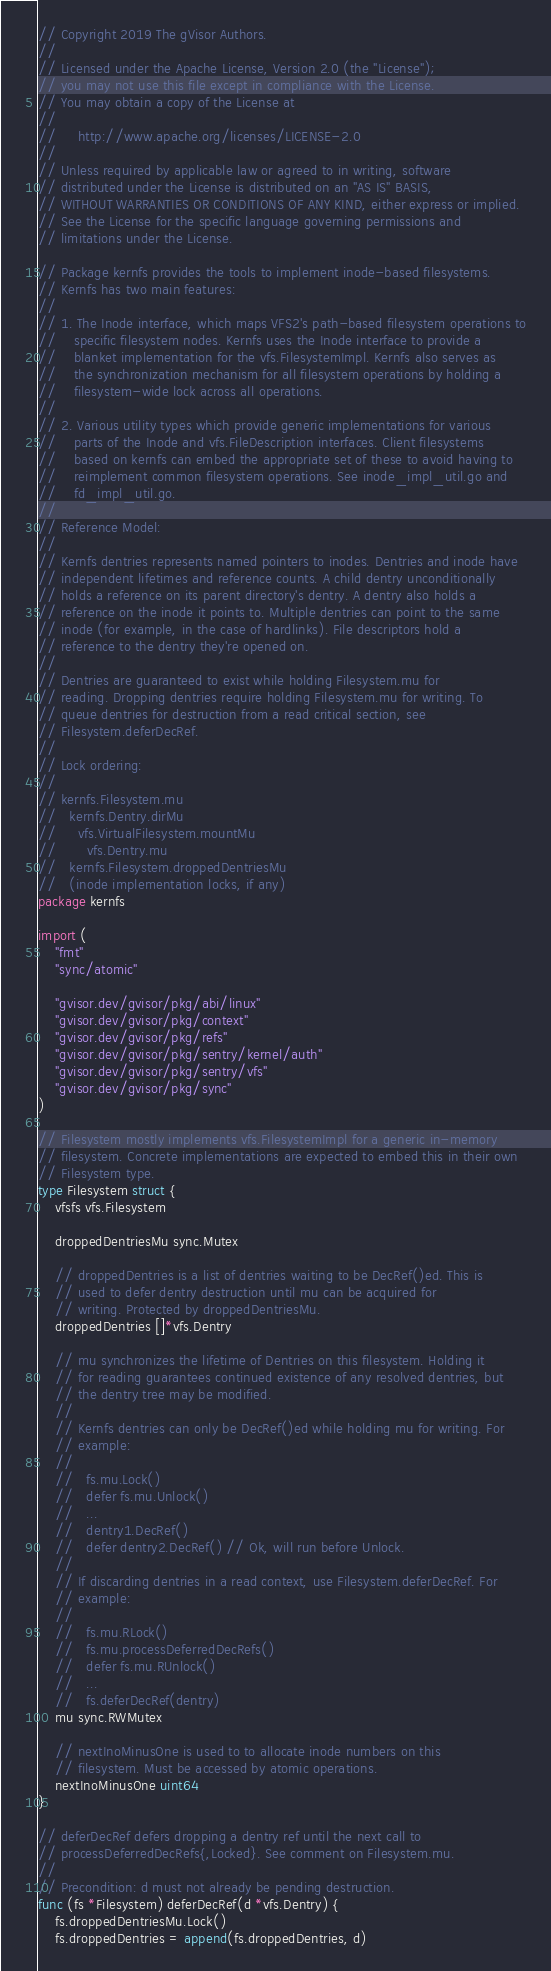<code> <loc_0><loc_0><loc_500><loc_500><_Go_>// Copyright 2019 The gVisor Authors.
//
// Licensed under the Apache License, Version 2.0 (the "License");
// you may not use this file except in compliance with the License.
// You may obtain a copy of the License at
//
//     http://www.apache.org/licenses/LICENSE-2.0
//
// Unless required by applicable law or agreed to in writing, software
// distributed under the License is distributed on an "AS IS" BASIS,
// WITHOUT WARRANTIES OR CONDITIONS OF ANY KIND, either express or implied.
// See the License for the specific language governing permissions and
// limitations under the License.

// Package kernfs provides the tools to implement inode-based filesystems.
// Kernfs has two main features:
//
// 1. The Inode interface, which maps VFS2's path-based filesystem operations to
//    specific filesystem nodes. Kernfs uses the Inode interface to provide a
//    blanket implementation for the vfs.FilesystemImpl. Kernfs also serves as
//    the synchronization mechanism for all filesystem operations by holding a
//    filesystem-wide lock across all operations.
//
// 2. Various utility types which provide generic implementations for various
//    parts of the Inode and vfs.FileDescription interfaces. Client filesystems
//    based on kernfs can embed the appropriate set of these to avoid having to
//    reimplement common filesystem operations. See inode_impl_util.go and
//    fd_impl_util.go.
//
// Reference Model:
//
// Kernfs dentries represents named pointers to inodes. Dentries and inode have
// independent lifetimes and reference counts. A child dentry unconditionally
// holds a reference on its parent directory's dentry. A dentry also holds a
// reference on the inode it points to. Multiple dentries can point to the same
// inode (for example, in the case of hardlinks). File descriptors hold a
// reference to the dentry they're opened on.
//
// Dentries are guaranteed to exist while holding Filesystem.mu for
// reading. Dropping dentries require holding Filesystem.mu for writing. To
// queue dentries for destruction from a read critical section, see
// Filesystem.deferDecRef.
//
// Lock ordering:
//
// kernfs.Filesystem.mu
//   kernfs.Dentry.dirMu
//     vfs.VirtualFilesystem.mountMu
//       vfs.Dentry.mu
//   kernfs.Filesystem.droppedDentriesMu
//   (inode implementation locks, if any)
package kernfs

import (
	"fmt"
	"sync/atomic"

	"gvisor.dev/gvisor/pkg/abi/linux"
	"gvisor.dev/gvisor/pkg/context"
	"gvisor.dev/gvisor/pkg/refs"
	"gvisor.dev/gvisor/pkg/sentry/kernel/auth"
	"gvisor.dev/gvisor/pkg/sentry/vfs"
	"gvisor.dev/gvisor/pkg/sync"
)

// Filesystem mostly implements vfs.FilesystemImpl for a generic in-memory
// filesystem. Concrete implementations are expected to embed this in their own
// Filesystem type.
type Filesystem struct {
	vfsfs vfs.Filesystem

	droppedDentriesMu sync.Mutex

	// droppedDentries is a list of dentries waiting to be DecRef()ed. This is
	// used to defer dentry destruction until mu can be acquired for
	// writing. Protected by droppedDentriesMu.
	droppedDentries []*vfs.Dentry

	// mu synchronizes the lifetime of Dentries on this filesystem. Holding it
	// for reading guarantees continued existence of any resolved dentries, but
	// the dentry tree may be modified.
	//
	// Kernfs dentries can only be DecRef()ed while holding mu for writing. For
	// example:
	//
	//   fs.mu.Lock()
	//   defer fs.mu.Unlock()
	//   ...
	//   dentry1.DecRef()
	//   defer dentry2.DecRef() // Ok, will run before Unlock.
	//
	// If discarding dentries in a read context, use Filesystem.deferDecRef. For
	// example:
	//
	//   fs.mu.RLock()
	//   fs.mu.processDeferredDecRefs()
	//   defer fs.mu.RUnlock()
	//   ...
	//   fs.deferDecRef(dentry)
	mu sync.RWMutex

	// nextInoMinusOne is used to to allocate inode numbers on this
	// filesystem. Must be accessed by atomic operations.
	nextInoMinusOne uint64
}

// deferDecRef defers dropping a dentry ref until the next call to
// processDeferredDecRefs{,Locked}. See comment on Filesystem.mu.
//
// Precondition: d must not already be pending destruction.
func (fs *Filesystem) deferDecRef(d *vfs.Dentry) {
	fs.droppedDentriesMu.Lock()
	fs.droppedDentries = append(fs.droppedDentries, d)</code> 